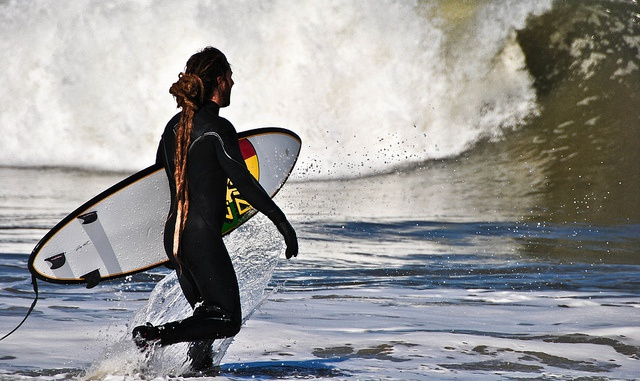Describe the objects in this image and their specific colors. I can see people in darkgray, black, maroon, gray, and lightgray tones and surfboard in darkgray, black, and lightgray tones in this image. 